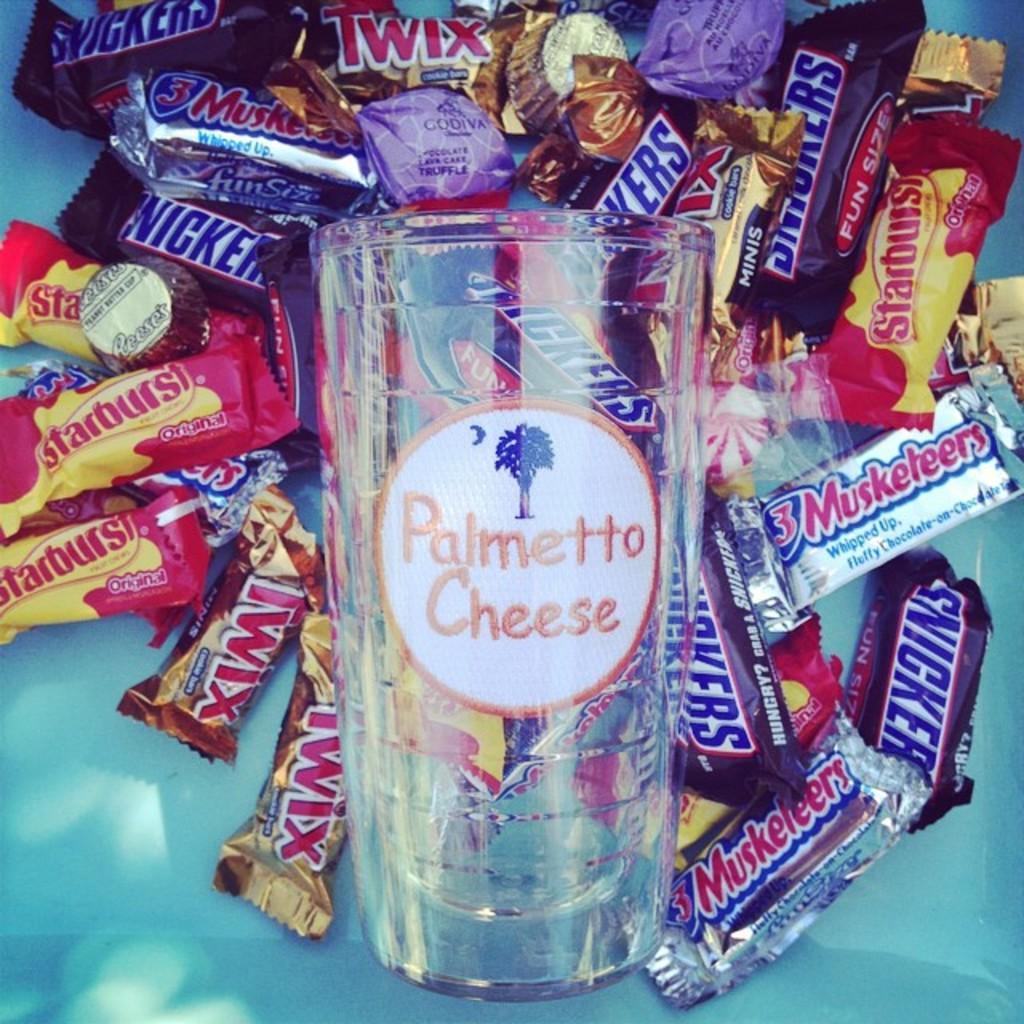Describe this image in one or two sentences. In this image there are chocolates as we can see in middle of this image and there is a glass in middle of this image. 